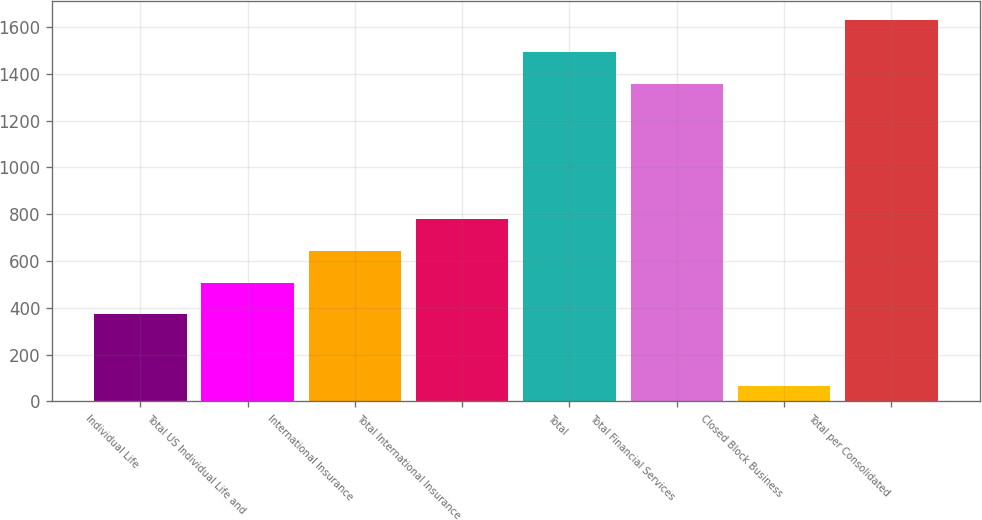<chart> <loc_0><loc_0><loc_500><loc_500><bar_chart><fcel>Individual Life<fcel>Total US Individual Life and<fcel>International Insurance<fcel>Total International Insurance<fcel>Total<fcel>Total Financial Services<fcel>Closed Block Business<fcel>Total per Consolidated<nl><fcel>372<fcel>507.7<fcel>643.4<fcel>779.1<fcel>1492.7<fcel>1357<fcel>67<fcel>1628.4<nl></chart> 